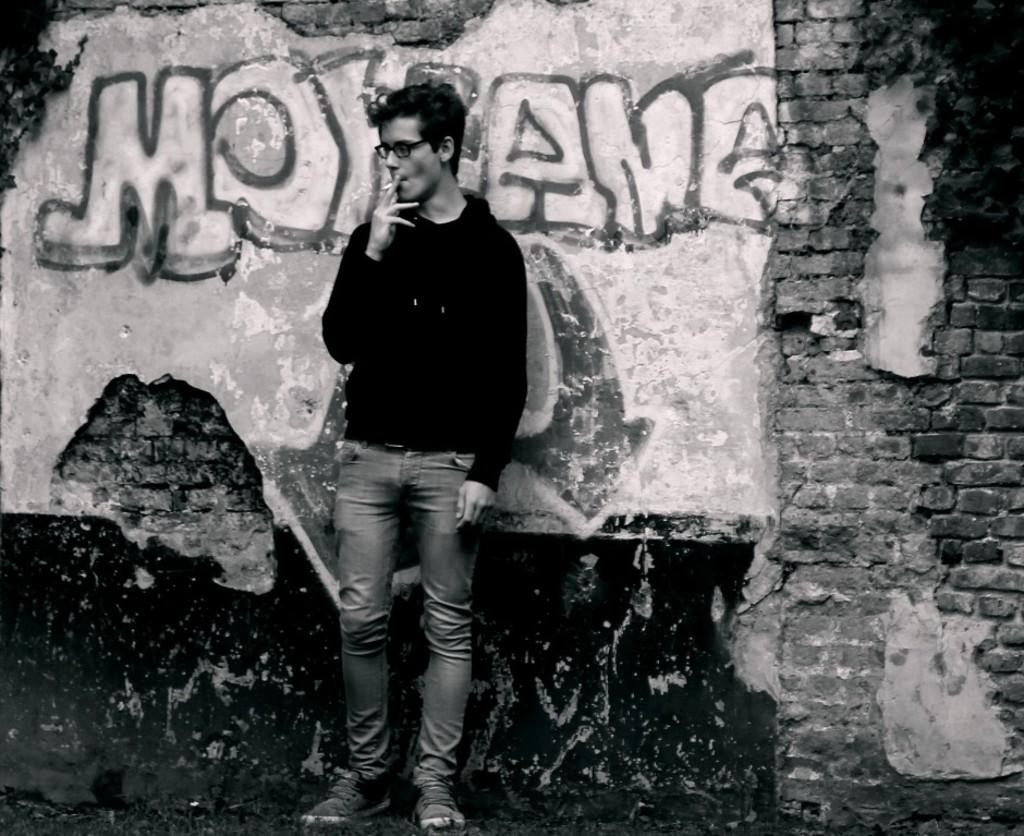What is the main subject of the image? There is a person in the image. What is the person doing in the image? The person is smoking. Can you describe any additional details in the image? There is text written on the wall in the image. What type of trees can be seen in the image? There are no trees present in the image. What is the topic of the argument taking place in the image? There is no argument present in the image; it only shows a person smoking and text on the wall. 